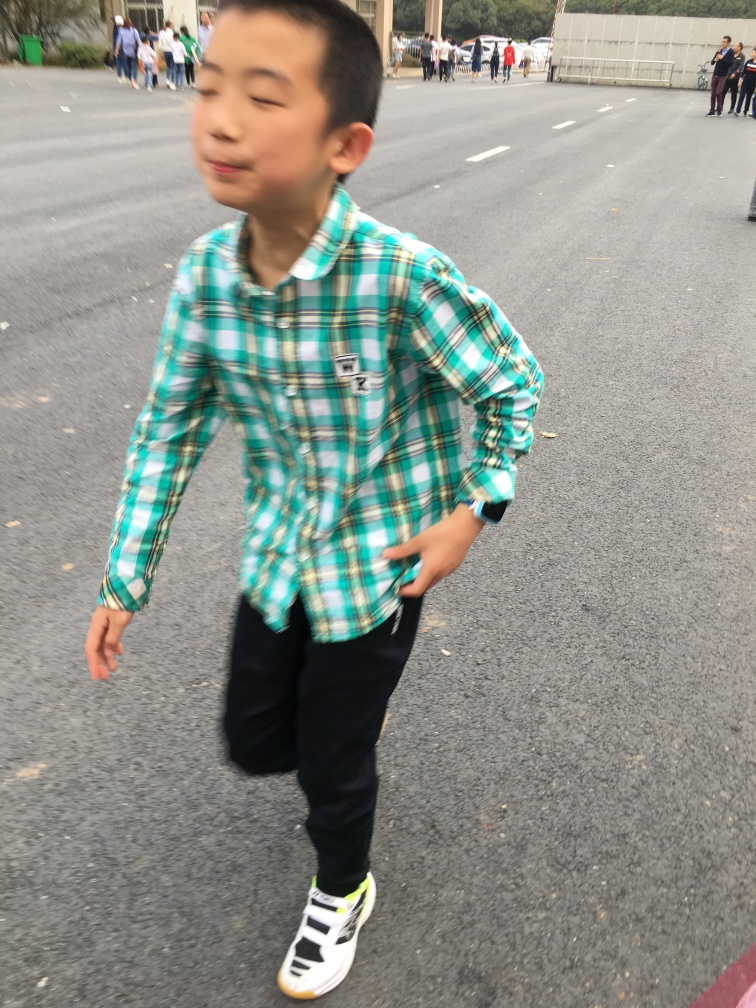Does the image have good overall sharpness? The sharpness of the image is not optimal. There is noticeable motion blur, particularly evident on the child's face and hands, suggesting movement during the capture. This effect creates a sense of action but compromises the overall sharpness and detail that one might expect from a still photograph. 